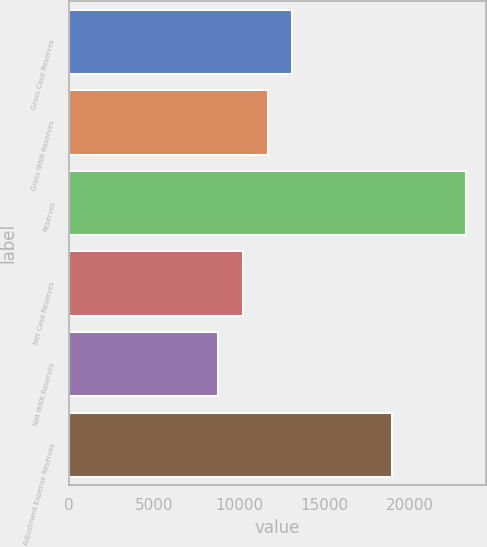<chart> <loc_0><loc_0><loc_500><loc_500><bar_chart><fcel>Gross Case Reserves<fcel>Gross IBNR Reserves<fcel>Reserves<fcel>Net Case Reserves<fcel>Net IBNR Reserves<fcel>Adjustment Expense Reserves<nl><fcel>13097.2<fcel>11643.8<fcel>23271<fcel>10190.4<fcel>8737<fcel>18927<nl></chart> 